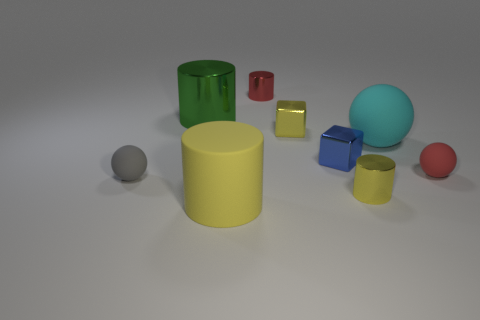Add 1 tiny blue rubber blocks. How many objects exist? 10 Subtract all blue cylinders. Subtract all gray balls. How many cylinders are left? 4 Subtract all blocks. How many objects are left? 7 Add 2 gray rubber things. How many gray rubber things are left? 3 Add 6 small gray spheres. How many small gray spheres exist? 7 Subtract 2 yellow cylinders. How many objects are left? 7 Subtract all metal blocks. Subtract all big green cylinders. How many objects are left? 6 